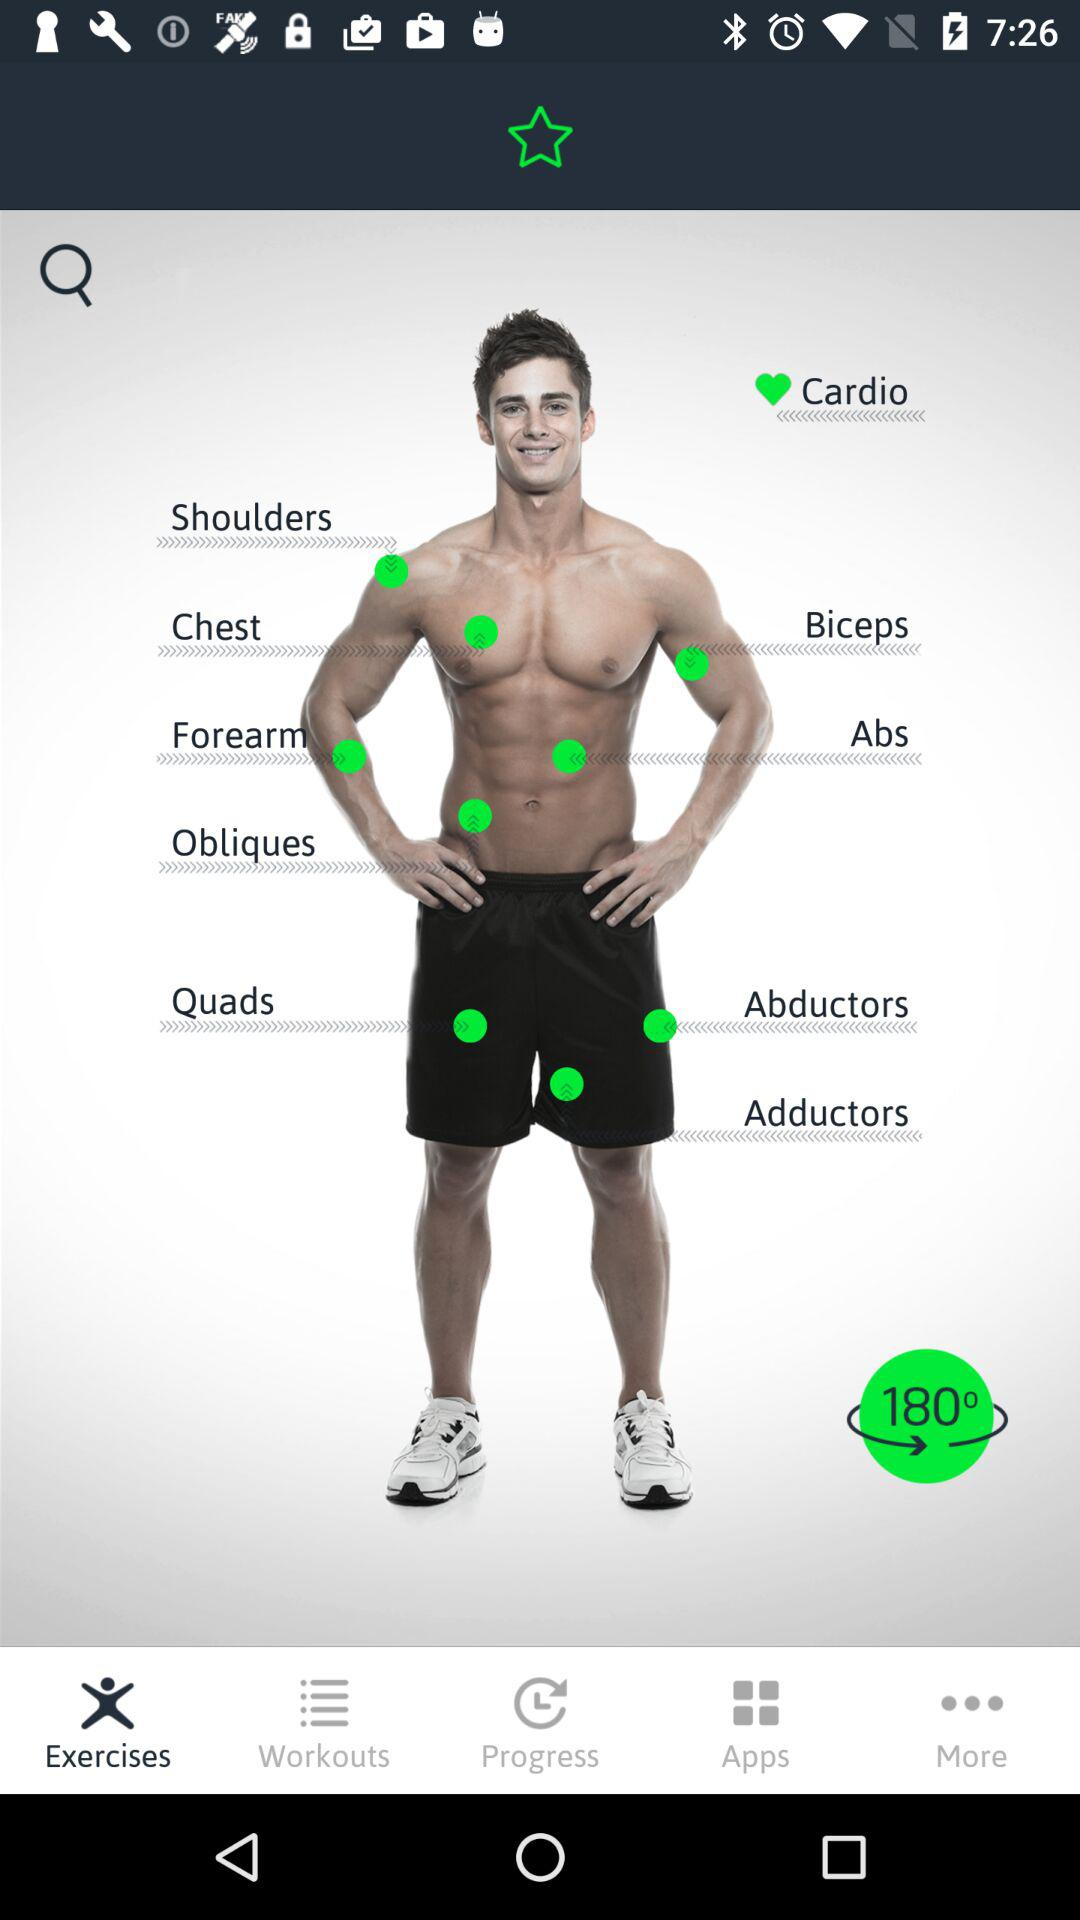What is the selected option? The selected option is "Exercises". 